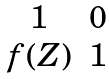<formula> <loc_0><loc_0><loc_500><loc_500>\begin{matrix} 1 & 0 \\ f ( Z ) & 1 \\ \end{matrix}</formula> 